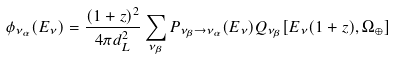Convert formula to latex. <formula><loc_0><loc_0><loc_500><loc_500>\phi _ { \nu _ { \alpha } } ( E _ { \nu } ) = \frac { ( 1 + z ) ^ { 2 } } { 4 \pi d _ { L } ^ { 2 } } \sum _ { \nu _ { \beta } } P _ { \nu _ { \beta } \to \nu _ { \alpha } } ( E _ { \nu } ) Q _ { \nu _ { \beta } } [ E _ { \nu } ( 1 + z ) , \Omega _ { \oplus } ]</formula> 